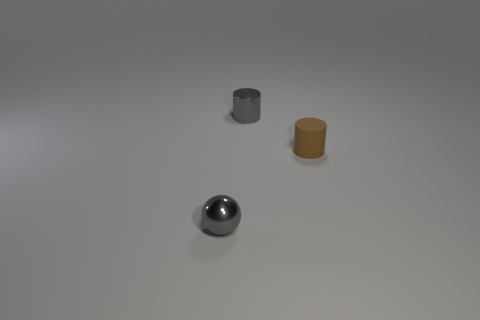What is the shape of the gray object that is the same size as the gray shiny cylinder?
Offer a terse response. Sphere. What is the material of the gray sphere in front of the tiny gray object that is behind the small thing that is left of the metal cylinder?
Your answer should be very brief. Metal. Does the gray cylinder have the same size as the brown matte cylinder?
Offer a very short reply. Yes. What is the gray cylinder made of?
Your answer should be very brief. Metal. What is the material of the sphere that is the same color as the shiny cylinder?
Give a very brief answer. Metal. There is a small gray metallic object that is in front of the gray metal cylinder; is its shape the same as the matte thing?
Keep it short and to the point. No. What number of things are tiny matte objects or small gray metallic balls?
Provide a short and direct response. 2. Is the cylinder that is on the left side of the matte cylinder made of the same material as the small brown object?
Offer a terse response. No. What size is the brown matte thing?
Keep it short and to the point. Small. There is a tiny object that is the same color as the small shiny cylinder; what shape is it?
Provide a succinct answer. Sphere. 